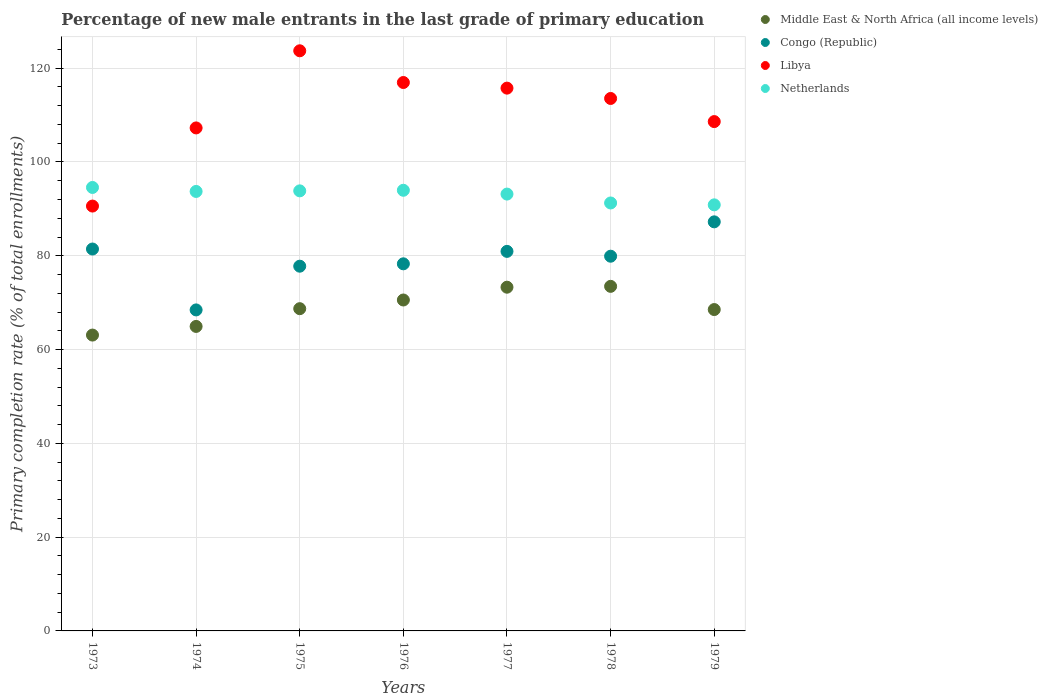How many different coloured dotlines are there?
Offer a very short reply. 4. What is the percentage of new male entrants in Middle East & North Africa (all income levels) in 1979?
Keep it short and to the point. 68.53. Across all years, what is the maximum percentage of new male entrants in Congo (Republic)?
Your answer should be very brief. 87.23. Across all years, what is the minimum percentage of new male entrants in Netherlands?
Offer a very short reply. 90.86. In which year was the percentage of new male entrants in Congo (Republic) maximum?
Give a very brief answer. 1979. In which year was the percentage of new male entrants in Netherlands minimum?
Offer a terse response. 1979. What is the total percentage of new male entrants in Libya in the graph?
Provide a short and direct response. 776.43. What is the difference between the percentage of new male entrants in Congo (Republic) in 1975 and that in 1976?
Provide a succinct answer. -0.51. What is the difference between the percentage of new male entrants in Netherlands in 1979 and the percentage of new male entrants in Middle East & North Africa (all income levels) in 1977?
Provide a succinct answer. 17.56. What is the average percentage of new male entrants in Congo (Republic) per year?
Offer a very short reply. 79.15. In the year 1976, what is the difference between the percentage of new male entrants in Libya and percentage of new male entrants in Middle East & North Africa (all income levels)?
Ensure brevity in your answer.  46.38. What is the ratio of the percentage of new male entrants in Congo (Republic) in 1975 to that in 1978?
Keep it short and to the point. 0.97. Is the percentage of new male entrants in Libya in 1975 less than that in 1979?
Your answer should be very brief. No. What is the difference between the highest and the second highest percentage of new male entrants in Congo (Republic)?
Your response must be concise. 5.8. What is the difference between the highest and the lowest percentage of new male entrants in Netherlands?
Your answer should be compact. 3.71. Is the sum of the percentage of new male entrants in Netherlands in 1973 and 1975 greater than the maximum percentage of new male entrants in Congo (Republic) across all years?
Your response must be concise. Yes. Is the percentage of new male entrants in Netherlands strictly less than the percentage of new male entrants in Libya over the years?
Make the answer very short. No. What is the difference between two consecutive major ticks on the Y-axis?
Offer a terse response. 20. Where does the legend appear in the graph?
Make the answer very short. Top right. How many legend labels are there?
Offer a terse response. 4. What is the title of the graph?
Provide a succinct answer. Percentage of new male entrants in the last grade of primary education. Does "Belgium" appear as one of the legend labels in the graph?
Give a very brief answer. No. What is the label or title of the X-axis?
Provide a short and direct response. Years. What is the label or title of the Y-axis?
Provide a short and direct response. Primary completion rate (% of total enrollments). What is the Primary completion rate (% of total enrollments) of Middle East & North Africa (all income levels) in 1973?
Make the answer very short. 63.09. What is the Primary completion rate (% of total enrollments) in Congo (Republic) in 1973?
Your response must be concise. 81.44. What is the Primary completion rate (% of total enrollments) of Libya in 1973?
Your answer should be very brief. 90.6. What is the Primary completion rate (% of total enrollments) in Netherlands in 1973?
Your answer should be compact. 94.57. What is the Primary completion rate (% of total enrollments) in Middle East & North Africa (all income levels) in 1974?
Ensure brevity in your answer.  64.93. What is the Primary completion rate (% of total enrollments) in Congo (Republic) in 1974?
Make the answer very short. 68.45. What is the Primary completion rate (% of total enrollments) of Libya in 1974?
Make the answer very short. 107.26. What is the Primary completion rate (% of total enrollments) in Netherlands in 1974?
Offer a terse response. 93.72. What is the Primary completion rate (% of total enrollments) of Middle East & North Africa (all income levels) in 1975?
Give a very brief answer. 68.72. What is the Primary completion rate (% of total enrollments) of Congo (Republic) in 1975?
Your answer should be compact. 77.78. What is the Primary completion rate (% of total enrollments) in Libya in 1975?
Your answer should be compact. 123.71. What is the Primary completion rate (% of total enrollments) of Netherlands in 1975?
Ensure brevity in your answer.  93.84. What is the Primary completion rate (% of total enrollments) of Middle East & North Africa (all income levels) in 1976?
Ensure brevity in your answer.  70.57. What is the Primary completion rate (% of total enrollments) of Congo (Republic) in 1976?
Your answer should be very brief. 78.28. What is the Primary completion rate (% of total enrollments) in Libya in 1976?
Give a very brief answer. 116.95. What is the Primary completion rate (% of total enrollments) of Netherlands in 1976?
Offer a terse response. 93.97. What is the Primary completion rate (% of total enrollments) of Middle East & North Africa (all income levels) in 1977?
Your answer should be compact. 73.3. What is the Primary completion rate (% of total enrollments) in Congo (Republic) in 1977?
Your answer should be very brief. 80.94. What is the Primary completion rate (% of total enrollments) of Libya in 1977?
Your answer should be very brief. 115.75. What is the Primary completion rate (% of total enrollments) in Netherlands in 1977?
Offer a terse response. 93.16. What is the Primary completion rate (% of total enrollments) in Middle East & North Africa (all income levels) in 1978?
Your answer should be compact. 73.48. What is the Primary completion rate (% of total enrollments) of Congo (Republic) in 1978?
Your response must be concise. 79.91. What is the Primary completion rate (% of total enrollments) of Libya in 1978?
Ensure brevity in your answer.  113.54. What is the Primary completion rate (% of total enrollments) of Netherlands in 1978?
Keep it short and to the point. 91.26. What is the Primary completion rate (% of total enrollments) in Middle East & North Africa (all income levels) in 1979?
Offer a terse response. 68.53. What is the Primary completion rate (% of total enrollments) in Congo (Republic) in 1979?
Ensure brevity in your answer.  87.23. What is the Primary completion rate (% of total enrollments) in Libya in 1979?
Keep it short and to the point. 108.61. What is the Primary completion rate (% of total enrollments) of Netherlands in 1979?
Keep it short and to the point. 90.86. Across all years, what is the maximum Primary completion rate (% of total enrollments) in Middle East & North Africa (all income levels)?
Make the answer very short. 73.48. Across all years, what is the maximum Primary completion rate (% of total enrollments) in Congo (Republic)?
Your answer should be compact. 87.23. Across all years, what is the maximum Primary completion rate (% of total enrollments) in Libya?
Your response must be concise. 123.71. Across all years, what is the maximum Primary completion rate (% of total enrollments) of Netherlands?
Make the answer very short. 94.57. Across all years, what is the minimum Primary completion rate (% of total enrollments) in Middle East & North Africa (all income levels)?
Provide a short and direct response. 63.09. Across all years, what is the minimum Primary completion rate (% of total enrollments) of Congo (Republic)?
Your response must be concise. 68.45. Across all years, what is the minimum Primary completion rate (% of total enrollments) in Libya?
Keep it short and to the point. 90.6. Across all years, what is the minimum Primary completion rate (% of total enrollments) in Netherlands?
Make the answer very short. 90.86. What is the total Primary completion rate (% of total enrollments) in Middle East & North Africa (all income levels) in the graph?
Your answer should be compact. 482.62. What is the total Primary completion rate (% of total enrollments) of Congo (Republic) in the graph?
Provide a succinct answer. 554.03. What is the total Primary completion rate (% of total enrollments) of Libya in the graph?
Make the answer very short. 776.43. What is the total Primary completion rate (% of total enrollments) of Netherlands in the graph?
Your answer should be compact. 651.37. What is the difference between the Primary completion rate (% of total enrollments) of Middle East & North Africa (all income levels) in 1973 and that in 1974?
Keep it short and to the point. -1.84. What is the difference between the Primary completion rate (% of total enrollments) in Congo (Republic) in 1973 and that in 1974?
Offer a terse response. 12.99. What is the difference between the Primary completion rate (% of total enrollments) in Libya in 1973 and that in 1974?
Ensure brevity in your answer.  -16.66. What is the difference between the Primary completion rate (% of total enrollments) of Netherlands in 1973 and that in 1974?
Keep it short and to the point. 0.85. What is the difference between the Primary completion rate (% of total enrollments) of Middle East & North Africa (all income levels) in 1973 and that in 1975?
Offer a terse response. -5.63. What is the difference between the Primary completion rate (% of total enrollments) in Congo (Republic) in 1973 and that in 1975?
Keep it short and to the point. 3.66. What is the difference between the Primary completion rate (% of total enrollments) of Libya in 1973 and that in 1975?
Provide a short and direct response. -33.11. What is the difference between the Primary completion rate (% of total enrollments) in Netherlands in 1973 and that in 1975?
Provide a short and direct response. 0.73. What is the difference between the Primary completion rate (% of total enrollments) in Middle East & North Africa (all income levels) in 1973 and that in 1976?
Give a very brief answer. -7.48. What is the difference between the Primary completion rate (% of total enrollments) in Congo (Republic) in 1973 and that in 1976?
Your answer should be very brief. 3.16. What is the difference between the Primary completion rate (% of total enrollments) of Libya in 1973 and that in 1976?
Keep it short and to the point. -26.35. What is the difference between the Primary completion rate (% of total enrollments) in Netherlands in 1973 and that in 1976?
Your answer should be compact. 0.6. What is the difference between the Primary completion rate (% of total enrollments) in Middle East & North Africa (all income levels) in 1973 and that in 1977?
Your answer should be compact. -10.21. What is the difference between the Primary completion rate (% of total enrollments) in Congo (Republic) in 1973 and that in 1977?
Offer a terse response. 0.5. What is the difference between the Primary completion rate (% of total enrollments) of Libya in 1973 and that in 1977?
Give a very brief answer. -25.15. What is the difference between the Primary completion rate (% of total enrollments) of Netherlands in 1973 and that in 1977?
Offer a very short reply. 1.41. What is the difference between the Primary completion rate (% of total enrollments) in Middle East & North Africa (all income levels) in 1973 and that in 1978?
Offer a terse response. -10.39. What is the difference between the Primary completion rate (% of total enrollments) in Congo (Republic) in 1973 and that in 1978?
Your answer should be very brief. 1.53. What is the difference between the Primary completion rate (% of total enrollments) of Libya in 1973 and that in 1978?
Offer a very short reply. -22.95. What is the difference between the Primary completion rate (% of total enrollments) of Netherlands in 1973 and that in 1978?
Ensure brevity in your answer.  3.31. What is the difference between the Primary completion rate (% of total enrollments) in Middle East & North Africa (all income levels) in 1973 and that in 1979?
Keep it short and to the point. -5.44. What is the difference between the Primary completion rate (% of total enrollments) in Congo (Republic) in 1973 and that in 1979?
Offer a terse response. -5.8. What is the difference between the Primary completion rate (% of total enrollments) of Libya in 1973 and that in 1979?
Your answer should be very brief. -18.01. What is the difference between the Primary completion rate (% of total enrollments) in Netherlands in 1973 and that in 1979?
Your response must be concise. 3.71. What is the difference between the Primary completion rate (% of total enrollments) in Middle East & North Africa (all income levels) in 1974 and that in 1975?
Ensure brevity in your answer.  -3.78. What is the difference between the Primary completion rate (% of total enrollments) in Congo (Republic) in 1974 and that in 1975?
Give a very brief answer. -9.32. What is the difference between the Primary completion rate (% of total enrollments) in Libya in 1974 and that in 1975?
Keep it short and to the point. -16.45. What is the difference between the Primary completion rate (% of total enrollments) of Netherlands in 1974 and that in 1975?
Your answer should be compact. -0.12. What is the difference between the Primary completion rate (% of total enrollments) in Middle East & North Africa (all income levels) in 1974 and that in 1976?
Keep it short and to the point. -5.63. What is the difference between the Primary completion rate (% of total enrollments) of Congo (Republic) in 1974 and that in 1976?
Give a very brief answer. -9.83. What is the difference between the Primary completion rate (% of total enrollments) of Libya in 1974 and that in 1976?
Give a very brief answer. -9.69. What is the difference between the Primary completion rate (% of total enrollments) in Netherlands in 1974 and that in 1976?
Offer a very short reply. -0.25. What is the difference between the Primary completion rate (% of total enrollments) in Middle East & North Africa (all income levels) in 1974 and that in 1977?
Keep it short and to the point. -8.37. What is the difference between the Primary completion rate (% of total enrollments) of Congo (Republic) in 1974 and that in 1977?
Your answer should be very brief. -12.48. What is the difference between the Primary completion rate (% of total enrollments) in Libya in 1974 and that in 1977?
Your answer should be very brief. -8.49. What is the difference between the Primary completion rate (% of total enrollments) of Netherlands in 1974 and that in 1977?
Keep it short and to the point. 0.56. What is the difference between the Primary completion rate (% of total enrollments) in Middle East & North Africa (all income levels) in 1974 and that in 1978?
Provide a short and direct response. -8.55. What is the difference between the Primary completion rate (% of total enrollments) of Congo (Republic) in 1974 and that in 1978?
Offer a very short reply. -11.45. What is the difference between the Primary completion rate (% of total enrollments) of Libya in 1974 and that in 1978?
Provide a succinct answer. -6.28. What is the difference between the Primary completion rate (% of total enrollments) in Netherlands in 1974 and that in 1978?
Your answer should be very brief. 2.46. What is the difference between the Primary completion rate (% of total enrollments) in Middle East & North Africa (all income levels) in 1974 and that in 1979?
Your answer should be compact. -3.6. What is the difference between the Primary completion rate (% of total enrollments) in Congo (Republic) in 1974 and that in 1979?
Keep it short and to the point. -18.78. What is the difference between the Primary completion rate (% of total enrollments) of Libya in 1974 and that in 1979?
Make the answer very short. -1.35. What is the difference between the Primary completion rate (% of total enrollments) of Netherlands in 1974 and that in 1979?
Give a very brief answer. 2.86. What is the difference between the Primary completion rate (% of total enrollments) of Middle East & North Africa (all income levels) in 1975 and that in 1976?
Your response must be concise. -1.85. What is the difference between the Primary completion rate (% of total enrollments) of Congo (Republic) in 1975 and that in 1976?
Keep it short and to the point. -0.51. What is the difference between the Primary completion rate (% of total enrollments) in Libya in 1975 and that in 1976?
Your response must be concise. 6.76. What is the difference between the Primary completion rate (% of total enrollments) in Netherlands in 1975 and that in 1976?
Your response must be concise. -0.12. What is the difference between the Primary completion rate (% of total enrollments) in Middle East & North Africa (all income levels) in 1975 and that in 1977?
Your response must be concise. -4.58. What is the difference between the Primary completion rate (% of total enrollments) of Congo (Republic) in 1975 and that in 1977?
Ensure brevity in your answer.  -3.16. What is the difference between the Primary completion rate (% of total enrollments) of Libya in 1975 and that in 1977?
Offer a terse response. 7.96. What is the difference between the Primary completion rate (% of total enrollments) in Netherlands in 1975 and that in 1977?
Provide a short and direct response. 0.69. What is the difference between the Primary completion rate (% of total enrollments) of Middle East & North Africa (all income levels) in 1975 and that in 1978?
Give a very brief answer. -4.76. What is the difference between the Primary completion rate (% of total enrollments) of Congo (Republic) in 1975 and that in 1978?
Ensure brevity in your answer.  -2.13. What is the difference between the Primary completion rate (% of total enrollments) in Libya in 1975 and that in 1978?
Your answer should be compact. 10.17. What is the difference between the Primary completion rate (% of total enrollments) of Netherlands in 1975 and that in 1978?
Make the answer very short. 2.58. What is the difference between the Primary completion rate (% of total enrollments) in Middle East & North Africa (all income levels) in 1975 and that in 1979?
Make the answer very short. 0.19. What is the difference between the Primary completion rate (% of total enrollments) of Congo (Republic) in 1975 and that in 1979?
Keep it short and to the point. -9.46. What is the difference between the Primary completion rate (% of total enrollments) in Libya in 1975 and that in 1979?
Provide a succinct answer. 15.1. What is the difference between the Primary completion rate (% of total enrollments) of Netherlands in 1975 and that in 1979?
Your answer should be compact. 2.98. What is the difference between the Primary completion rate (% of total enrollments) in Middle East & North Africa (all income levels) in 1976 and that in 1977?
Offer a terse response. -2.73. What is the difference between the Primary completion rate (% of total enrollments) of Congo (Republic) in 1976 and that in 1977?
Offer a terse response. -2.65. What is the difference between the Primary completion rate (% of total enrollments) of Libya in 1976 and that in 1977?
Your answer should be compact. 1.2. What is the difference between the Primary completion rate (% of total enrollments) of Netherlands in 1976 and that in 1977?
Keep it short and to the point. 0.81. What is the difference between the Primary completion rate (% of total enrollments) of Middle East & North Africa (all income levels) in 1976 and that in 1978?
Provide a succinct answer. -2.91. What is the difference between the Primary completion rate (% of total enrollments) of Congo (Republic) in 1976 and that in 1978?
Provide a short and direct response. -1.62. What is the difference between the Primary completion rate (% of total enrollments) of Libya in 1976 and that in 1978?
Provide a short and direct response. 3.4. What is the difference between the Primary completion rate (% of total enrollments) in Netherlands in 1976 and that in 1978?
Your answer should be very brief. 2.71. What is the difference between the Primary completion rate (% of total enrollments) of Middle East & North Africa (all income levels) in 1976 and that in 1979?
Give a very brief answer. 2.04. What is the difference between the Primary completion rate (% of total enrollments) of Congo (Republic) in 1976 and that in 1979?
Make the answer very short. -8.95. What is the difference between the Primary completion rate (% of total enrollments) of Libya in 1976 and that in 1979?
Make the answer very short. 8.33. What is the difference between the Primary completion rate (% of total enrollments) of Netherlands in 1976 and that in 1979?
Offer a terse response. 3.11. What is the difference between the Primary completion rate (% of total enrollments) of Middle East & North Africa (all income levels) in 1977 and that in 1978?
Provide a succinct answer. -0.18. What is the difference between the Primary completion rate (% of total enrollments) in Congo (Republic) in 1977 and that in 1978?
Make the answer very short. 1.03. What is the difference between the Primary completion rate (% of total enrollments) of Libya in 1977 and that in 1978?
Provide a succinct answer. 2.2. What is the difference between the Primary completion rate (% of total enrollments) in Netherlands in 1977 and that in 1978?
Give a very brief answer. 1.9. What is the difference between the Primary completion rate (% of total enrollments) of Middle East & North Africa (all income levels) in 1977 and that in 1979?
Give a very brief answer. 4.77. What is the difference between the Primary completion rate (% of total enrollments) of Congo (Republic) in 1977 and that in 1979?
Provide a succinct answer. -6.3. What is the difference between the Primary completion rate (% of total enrollments) of Libya in 1977 and that in 1979?
Your response must be concise. 7.13. What is the difference between the Primary completion rate (% of total enrollments) of Netherlands in 1977 and that in 1979?
Provide a succinct answer. 2.3. What is the difference between the Primary completion rate (% of total enrollments) of Middle East & North Africa (all income levels) in 1978 and that in 1979?
Offer a very short reply. 4.95. What is the difference between the Primary completion rate (% of total enrollments) of Congo (Republic) in 1978 and that in 1979?
Provide a short and direct response. -7.33. What is the difference between the Primary completion rate (% of total enrollments) in Libya in 1978 and that in 1979?
Your response must be concise. 4.93. What is the difference between the Primary completion rate (% of total enrollments) of Netherlands in 1978 and that in 1979?
Provide a succinct answer. 0.4. What is the difference between the Primary completion rate (% of total enrollments) in Middle East & North Africa (all income levels) in 1973 and the Primary completion rate (% of total enrollments) in Congo (Republic) in 1974?
Make the answer very short. -5.36. What is the difference between the Primary completion rate (% of total enrollments) of Middle East & North Africa (all income levels) in 1973 and the Primary completion rate (% of total enrollments) of Libya in 1974?
Offer a very short reply. -44.17. What is the difference between the Primary completion rate (% of total enrollments) of Middle East & North Africa (all income levels) in 1973 and the Primary completion rate (% of total enrollments) of Netherlands in 1974?
Give a very brief answer. -30.63. What is the difference between the Primary completion rate (% of total enrollments) of Congo (Republic) in 1973 and the Primary completion rate (% of total enrollments) of Libya in 1974?
Make the answer very short. -25.82. What is the difference between the Primary completion rate (% of total enrollments) of Congo (Republic) in 1973 and the Primary completion rate (% of total enrollments) of Netherlands in 1974?
Keep it short and to the point. -12.28. What is the difference between the Primary completion rate (% of total enrollments) in Libya in 1973 and the Primary completion rate (% of total enrollments) in Netherlands in 1974?
Your answer should be compact. -3.12. What is the difference between the Primary completion rate (% of total enrollments) in Middle East & North Africa (all income levels) in 1973 and the Primary completion rate (% of total enrollments) in Congo (Republic) in 1975?
Provide a succinct answer. -14.69. What is the difference between the Primary completion rate (% of total enrollments) of Middle East & North Africa (all income levels) in 1973 and the Primary completion rate (% of total enrollments) of Libya in 1975?
Your answer should be compact. -60.62. What is the difference between the Primary completion rate (% of total enrollments) in Middle East & North Africa (all income levels) in 1973 and the Primary completion rate (% of total enrollments) in Netherlands in 1975?
Your answer should be compact. -30.75. What is the difference between the Primary completion rate (% of total enrollments) in Congo (Republic) in 1973 and the Primary completion rate (% of total enrollments) in Libya in 1975?
Your answer should be compact. -42.27. What is the difference between the Primary completion rate (% of total enrollments) of Congo (Republic) in 1973 and the Primary completion rate (% of total enrollments) of Netherlands in 1975?
Your answer should be very brief. -12.4. What is the difference between the Primary completion rate (% of total enrollments) of Libya in 1973 and the Primary completion rate (% of total enrollments) of Netherlands in 1975?
Provide a succinct answer. -3.24. What is the difference between the Primary completion rate (% of total enrollments) in Middle East & North Africa (all income levels) in 1973 and the Primary completion rate (% of total enrollments) in Congo (Republic) in 1976?
Offer a very short reply. -15.19. What is the difference between the Primary completion rate (% of total enrollments) in Middle East & North Africa (all income levels) in 1973 and the Primary completion rate (% of total enrollments) in Libya in 1976?
Keep it short and to the point. -53.86. What is the difference between the Primary completion rate (% of total enrollments) of Middle East & North Africa (all income levels) in 1973 and the Primary completion rate (% of total enrollments) of Netherlands in 1976?
Give a very brief answer. -30.88. What is the difference between the Primary completion rate (% of total enrollments) of Congo (Republic) in 1973 and the Primary completion rate (% of total enrollments) of Libya in 1976?
Offer a terse response. -35.51. What is the difference between the Primary completion rate (% of total enrollments) in Congo (Republic) in 1973 and the Primary completion rate (% of total enrollments) in Netherlands in 1976?
Make the answer very short. -12.53. What is the difference between the Primary completion rate (% of total enrollments) in Libya in 1973 and the Primary completion rate (% of total enrollments) in Netherlands in 1976?
Offer a terse response. -3.37. What is the difference between the Primary completion rate (% of total enrollments) in Middle East & North Africa (all income levels) in 1973 and the Primary completion rate (% of total enrollments) in Congo (Republic) in 1977?
Your answer should be very brief. -17.85. What is the difference between the Primary completion rate (% of total enrollments) of Middle East & North Africa (all income levels) in 1973 and the Primary completion rate (% of total enrollments) of Libya in 1977?
Provide a short and direct response. -52.66. What is the difference between the Primary completion rate (% of total enrollments) in Middle East & North Africa (all income levels) in 1973 and the Primary completion rate (% of total enrollments) in Netherlands in 1977?
Your answer should be compact. -30.07. What is the difference between the Primary completion rate (% of total enrollments) in Congo (Republic) in 1973 and the Primary completion rate (% of total enrollments) in Libya in 1977?
Make the answer very short. -34.31. What is the difference between the Primary completion rate (% of total enrollments) in Congo (Republic) in 1973 and the Primary completion rate (% of total enrollments) in Netherlands in 1977?
Offer a terse response. -11.72. What is the difference between the Primary completion rate (% of total enrollments) of Libya in 1973 and the Primary completion rate (% of total enrollments) of Netherlands in 1977?
Offer a very short reply. -2.56. What is the difference between the Primary completion rate (% of total enrollments) of Middle East & North Africa (all income levels) in 1973 and the Primary completion rate (% of total enrollments) of Congo (Republic) in 1978?
Your answer should be compact. -16.82. What is the difference between the Primary completion rate (% of total enrollments) in Middle East & North Africa (all income levels) in 1973 and the Primary completion rate (% of total enrollments) in Libya in 1978?
Offer a very short reply. -50.45. What is the difference between the Primary completion rate (% of total enrollments) of Middle East & North Africa (all income levels) in 1973 and the Primary completion rate (% of total enrollments) of Netherlands in 1978?
Provide a short and direct response. -28.17. What is the difference between the Primary completion rate (% of total enrollments) of Congo (Republic) in 1973 and the Primary completion rate (% of total enrollments) of Libya in 1978?
Make the answer very short. -32.11. What is the difference between the Primary completion rate (% of total enrollments) in Congo (Republic) in 1973 and the Primary completion rate (% of total enrollments) in Netherlands in 1978?
Give a very brief answer. -9.82. What is the difference between the Primary completion rate (% of total enrollments) in Libya in 1973 and the Primary completion rate (% of total enrollments) in Netherlands in 1978?
Provide a short and direct response. -0.66. What is the difference between the Primary completion rate (% of total enrollments) of Middle East & North Africa (all income levels) in 1973 and the Primary completion rate (% of total enrollments) of Congo (Republic) in 1979?
Your answer should be compact. -24.14. What is the difference between the Primary completion rate (% of total enrollments) in Middle East & North Africa (all income levels) in 1973 and the Primary completion rate (% of total enrollments) in Libya in 1979?
Offer a very short reply. -45.52. What is the difference between the Primary completion rate (% of total enrollments) of Middle East & North Africa (all income levels) in 1973 and the Primary completion rate (% of total enrollments) of Netherlands in 1979?
Provide a short and direct response. -27.77. What is the difference between the Primary completion rate (% of total enrollments) in Congo (Republic) in 1973 and the Primary completion rate (% of total enrollments) in Libya in 1979?
Ensure brevity in your answer.  -27.18. What is the difference between the Primary completion rate (% of total enrollments) in Congo (Republic) in 1973 and the Primary completion rate (% of total enrollments) in Netherlands in 1979?
Offer a very short reply. -9.42. What is the difference between the Primary completion rate (% of total enrollments) in Libya in 1973 and the Primary completion rate (% of total enrollments) in Netherlands in 1979?
Give a very brief answer. -0.26. What is the difference between the Primary completion rate (% of total enrollments) of Middle East & North Africa (all income levels) in 1974 and the Primary completion rate (% of total enrollments) of Congo (Republic) in 1975?
Keep it short and to the point. -12.84. What is the difference between the Primary completion rate (% of total enrollments) of Middle East & North Africa (all income levels) in 1974 and the Primary completion rate (% of total enrollments) of Libya in 1975?
Keep it short and to the point. -58.78. What is the difference between the Primary completion rate (% of total enrollments) in Middle East & North Africa (all income levels) in 1974 and the Primary completion rate (% of total enrollments) in Netherlands in 1975?
Offer a very short reply. -28.91. What is the difference between the Primary completion rate (% of total enrollments) of Congo (Republic) in 1974 and the Primary completion rate (% of total enrollments) of Libya in 1975?
Your answer should be compact. -55.26. What is the difference between the Primary completion rate (% of total enrollments) in Congo (Republic) in 1974 and the Primary completion rate (% of total enrollments) in Netherlands in 1975?
Make the answer very short. -25.39. What is the difference between the Primary completion rate (% of total enrollments) of Libya in 1974 and the Primary completion rate (% of total enrollments) of Netherlands in 1975?
Give a very brief answer. 13.42. What is the difference between the Primary completion rate (% of total enrollments) in Middle East & North Africa (all income levels) in 1974 and the Primary completion rate (% of total enrollments) in Congo (Republic) in 1976?
Provide a short and direct response. -13.35. What is the difference between the Primary completion rate (% of total enrollments) of Middle East & North Africa (all income levels) in 1974 and the Primary completion rate (% of total enrollments) of Libya in 1976?
Give a very brief answer. -52.01. What is the difference between the Primary completion rate (% of total enrollments) of Middle East & North Africa (all income levels) in 1974 and the Primary completion rate (% of total enrollments) of Netherlands in 1976?
Offer a very short reply. -29.03. What is the difference between the Primary completion rate (% of total enrollments) of Congo (Republic) in 1974 and the Primary completion rate (% of total enrollments) of Libya in 1976?
Make the answer very short. -48.5. What is the difference between the Primary completion rate (% of total enrollments) of Congo (Republic) in 1974 and the Primary completion rate (% of total enrollments) of Netherlands in 1976?
Your answer should be very brief. -25.51. What is the difference between the Primary completion rate (% of total enrollments) in Libya in 1974 and the Primary completion rate (% of total enrollments) in Netherlands in 1976?
Ensure brevity in your answer.  13.3. What is the difference between the Primary completion rate (% of total enrollments) in Middle East & North Africa (all income levels) in 1974 and the Primary completion rate (% of total enrollments) in Congo (Republic) in 1977?
Your response must be concise. -16. What is the difference between the Primary completion rate (% of total enrollments) of Middle East & North Africa (all income levels) in 1974 and the Primary completion rate (% of total enrollments) of Libya in 1977?
Provide a short and direct response. -50.82. What is the difference between the Primary completion rate (% of total enrollments) of Middle East & North Africa (all income levels) in 1974 and the Primary completion rate (% of total enrollments) of Netherlands in 1977?
Your answer should be very brief. -28.22. What is the difference between the Primary completion rate (% of total enrollments) in Congo (Republic) in 1974 and the Primary completion rate (% of total enrollments) in Libya in 1977?
Give a very brief answer. -47.3. What is the difference between the Primary completion rate (% of total enrollments) in Congo (Republic) in 1974 and the Primary completion rate (% of total enrollments) in Netherlands in 1977?
Offer a terse response. -24.7. What is the difference between the Primary completion rate (% of total enrollments) in Libya in 1974 and the Primary completion rate (% of total enrollments) in Netherlands in 1977?
Ensure brevity in your answer.  14.11. What is the difference between the Primary completion rate (% of total enrollments) in Middle East & North Africa (all income levels) in 1974 and the Primary completion rate (% of total enrollments) in Congo (Republic) in 1978?
Keep it short and to the point. -14.97. What is the difference between the Primary completion rate (% of total enrollments) of Middle East & North Africa (all income levels) in 1974 and the Primary completion rate (% of total enrollments) of Libya in 1978?
Offer a very short reply. -48.61. What is the difference between the Primary completion rate (% of total enrollments) of Middle East & North Africa (all income levels) in 1974 and the Primary completion rate (% of total enrollments) of Netherlands in 1978?
Provide a succinct answer. -26.33. What is the difference between the Primary completion rate (% of total enrollments) of Congo (Republic) in 1974 and the Primary completion rate (% of total enrollments) of Libya in 1978?
Make the answer very short. -45.09. What is the difference between the Primary completion rate (% of total enrollments) of Congo (Republic) in 1974 and the Primary completion rate (% of total enrollments) of Netherlands in 1978?
Provide a succinct answer. -22.81. What is the difference between the Primary completion rate (% of total enrollments) of Libya in 1974 and the Primary completion rate (% of total enrollments) of Netherlands in 1978?
Offer a very short reply. 16. What is the difference between the Primary completion rate (% of total enrollments) of Middle East & North Africa (all income levels) in 1974 and the Primary completion rate (% of total enrollments) of Congo (Republic) in 1979?
Your answer should be very brief. -22.3. What is the difference between the Primary completion rate (% of total enrollments) of Middle East & North Africa (all income levels) in 1974 and the Primary completion rate (% of total enrollments) of Libya in 1979?
Provide a succinct answer. -43.68. What is the difference between the Primary completion rate (% of total enrollments) in Middle East & North Africa (all income levels) in 1974 and the Primary completion rate (% of total enrollments) in Netherlands in 1979?
Ensure brevity in your answer.  -25.92. What is the difference between the Primary completion rate (% of total enrollments) of Congo (Republic) in 1974 and the Primary completion rate (% of total enrollments) of Libya in 1979?
Offer a very short reply. -40.16. What is the difference between the Primary completion rate (% of total enrollments) of Congo (Republic) in 1974 and the Primary completion rate (% of total enrollments) of Netherlands in 1979?
Your answer should be very brief. -22.41. What is the difference between the Primary completion rate (% of total enrollments) in Libya in 1974 and the Primary completion rate (% of total enrollments) in Netherlands in 1979?
Your answer should be compact. 16.4. What is the difference between the Primary completion rate (% of total enrollments) of Middle East & North Africa (all income levels) in 1975 and the Primary completion rate (% of total enrollments) of Congo (Republic) in 1976?
Offer a terse response. -9.57. What is the difference between the Primary completion rate (% of total enrollments) in Middle East & North Africa (all income levels) in 1975 and the Primary completion rate (% of total enrollments) in Libya in 1976?
Your response must be concise. -48.23. What is the difference between the Primary completion rate (% of total enrollments) in Middle East & North Africa (all income levels) in 1975 and the Primary completion rate (% of total enrollments) in Netherlands in 1976?
Your response must be concise. -25.25. What is the difference between the Primary completion rate (% of total enrollments) of Congo (Republic) in 1975 and the Primary completion rate (% of total enrollments) of Libya in 1976?
Offer a very short reply. -39.17. What is the difference between the Primary completion rate (% of total enrollments) in Congo (Republic) in 1975 and the Primary completion rate (% of total enrollments) in Netherlands in 1976?
Your response must be concise. -16.19. What is the difference between the Primary completion rate (% of total enrollments) of Libya in 1975 and the Primary completion rate (% of total enrollments) of Netherlands in 1976?
Offer a very short reply. 29.75. What is the difference between the Primary completion rate (% of total enrollments) in Middle East & North Africa (all income levels) in 1975 and the Primary completion rate (% of total enrollments) in Congo (Republic) in 1977?
Keep it short and to the point. -12.22. What is the difference between the Primary completion rate (% of total enrollments) in Middle East & North Africa (all income levels) in 1975 and the Primary completion rate (% of total enrollments) in Libya in 1977?
Provide a short and direct response. -47.03. What is the difference between the Primary completion rate (% of total enrollments) of Middle East & North Africa (all income levels) in 1975 and the Primary completion rate (% of total enrollments) of Netherlands in 1977?
Provide a succinct answer. -24.44. What is the difference between the Primary completion rate (% of total enrollments) of Congo (Republic) in 1975 and the Primary completion rate (% of total enrollments) of Libya in 1977?
Your answer should be compact. -37.97. What is the difference between the Primary completion rate (% of total enrollments) in Congo (Republic) in 1975 and the Primary completion rate (% of total enrollments) in Netherlands in 1977?
Provide a succinct answer. -15.38. What is the difference between the Primary completion rate (% of total enrollments) of Libya in 1975 and the Primary completion rate (% of total enrollments) of Netherlands in 1977?
Your response must be concise. 30.56. What is the difference between the Primary completion rate (% of total enrollments) of Middle East & North Africa (all income levels) in 1975 and the Primary completion rate (% of total enrollments) of Congo (Republic) in 1978?
Provide a short and direct response. -11.19. What is the difference between the Primary completion rate (% of total enrollments) in Middle East & North Africa (all income levels) in 1975 and the Primary completion rate (% of total enrollments) in Libya in 1978?
Ensure brevity in your answer.  -44.83. What is the difference between the Primary completion rate (% of total enrollments) in Middle East & North Africa (all income levels) in 1975 and the Primary completion rate (% of total enrollments) in Netherlands in 1978?
Your answer should be compact. -22.54. What is the difference between the Primary completion rate (% of total enrollments) of Congo (Republic) in 1975 and the Primary completion rate (% of total enrollments) of Libya in 1978?
Make the answer very short. -35.77. What is the difference between the Primary completion rate (% of total enrollments) of Congo (Republic) in 1975 and the Primary completion rate (% of total enrollments) of Netherlands in 1978?
Your response must be concise. -13.48. What is the difference between the Primary completion rate (% of total enrollments) in Libya in 1975 and the Primary completion rate (% of total enrollments) in Netherlands in 1978?
Provide a short and direct response. 32.45. What is the difference between the Primary completion rate (% of total enrollments) in Middle East & North Africa (all income levels) in 1975 and the Primary completion rate (% of total enrollments) in Congo (Republic) in 1979?
Make the answer very short. -18.52. What is the difference between the Primary completion rate (% of total enrollments) in Middle East & North Africa (all income levels) in 1975 and the Primary completion rate (% of total enrollments) in Libya in 1979?
Keep it short and to the point. -39.9. What is the difference between the Primary completion rate (% of total enrollments) in Middle East & North Africa (all income levels) in 1975 and the Primary completion rate (% of total enrollments) in Netherlands in 1979?
Give a very brief answer. -22.14. What is the difference between the Primary completion rate (% of total enrollments) of Congo (Republic) in 1975 and the Primary completion rate (% of total enrollments) of Libya in 1979?
Provide a succinct answer. -30.84. What is the difference between the Primary completion rate (% of total enrollments) of Congo (Republic) in 1975 and the Primary completion rate (% of total enrollments) of Netherlands in 1979?
Provide a succinct answer. -13.08. What is the difference between the Primary completion rate (% of total enrollments) in Libya in 1975 and the Primary completion rate (% of total enrollments) in Netherlands in 1979?
Keep it short and to the point. 32.85. What is the difference between the Primary completion rate (% of total enrollments) in Middle East & North Africa (all income levels) in 1976 and the Primary completion rate (% of total enrollments) in Congo (Republic) in 1977?
Your answer should be very brief. -10.37. What is the difference between the Primary completion rate (% of total enrollments) in Middle East & North Africa (all income levels) in 1976 and the Primary completion rate (% of total enrollments) in Libya in 1977?
Provide a short and direct response. -45.18. What is the difference between the Primary completion rate (% of total enrollments) in Middle East & North Africa (all income levels) in 1976 and the Primary completion rate (% of total enrollments) in Netherlands in 1977?
Your response must be concise. -22.59. What is the difference between the Primary completion rate (% of total enrollments) in Congo (Republic) in 1976 and the Primary completion rate (% of total enrollments) in Libya in 1977?
Your answer should be compact. -37.47. What is the difference between the Primary completion rate (% of total enrollments) of Congo (Republic) in 1976 and the Primary completion rate (% of total enrollments) of Netherlands in 1977?
Offer a very short reply. -14.87. What is the difference between the Primary completion rate (% of total enrollments) of Libya in 1976 and the Primary completion rate (% of total enrollments) of Netherlands in 1977?
Offer a very short reply. 23.79. What is the difference between the Primary completion rate (% of total enrollments) of Middle East & North Africa (all income levels) in 1976 and the Primary completion rate (% of total enrollments) of Congo (Republic) in 1978?
Make the answer very short. -9.34. What is the difference between the Primary completion rate (% of total enrollments) in Middle East & North Africa (all income levels) in 1976 and the Primary completion rate (% of total enrollments) in Libya in 1978?
Provide a short and direct response. -42.98. What is the difference between the Primary completion rate (% of total enrollments) of Middle East & North Africa (all income levels) in 1976 and the Primary completion rate (% of total enrollments) of Netherlands in 1978?
Your response must be concise. -20.69. What is the difference between the Primary completion rate (% of total enrollments) in Congo (Republic) in 1976 and the Primary completion rate (% of total enrollments) in Libya in 1978?
Keep it short and to the point. -35.26. What is the difference between the Primary completion rate (% of total enrollments) of Congo (Republic) in 1976 and the Primary completion rate (% of total enrollments) of Netherlands in 1978?
Your answer should be compact. -12.98. What is the difference between the Primary completion rate (% of total enrollments) in Libya in 1976 and the Primary completion rate (% of total enrollments) in Netherlands in 1978?
Your answer should be compact. 25.69. What is the difference between the Primary completion rate (% of total enrollments) of Middle East & North Africa (all income levels) in 1976 and the Primary completion rate (% of total enrollments) of Congo (Republic) in 1979?
Ensure brevity in your answer.  -16.67. What is the difference between the Primary completion rate (% of total enrollments) in Middle East & North Africa (all income levels) in 1976 and the Primary completion rate (% of total enrollments) in Libya in 1979?
Offer a terse response. -38.05. What is the difference between the Primary completion rate (% of total enrollments) of Middle East & North Africa (all income levels) in 1976 and the Primary completion rate (% of total enrollments) of Netherlands in 1979?
Ensure brevity in your answer.  -20.29. What is the difference between the Primary completion rate (% of total enrollments) in Congo (Republic) in 1976 and the Primary completion rate (% of total enrollments) in Libya in 1979?
Make the answer very short. -30.33. What is the difference between the Primary completion rate (% of total enrollments) of Congo (Republic) in 1976 and the Primary completion rate (% of total enrollments) of Netherlands in 1979?
Offer a very short reply. -12.58. What is the difference between the Primary completion rate (% of total enrollments) in Libya in 1976 and the Primary completion rate (% of total enrollments) in Netherlands in 1979?
Provide a short and direct response. 26.09. What is the difference between the Primary completion rate (% of total enrollments) in Middle East & North Africa (all income levels) in 1977 and the Primary completion rate (% of total enrollments) in Congo (Republic) in 1978?
Offer a very short reply. -6.61. What is the difference between the Primary completion rate (% of total enrollments) of Middle East & North Africa (all income levels) in 1977 and the Primary completion rate (% of total enrollments) of Libya in 1978?
Keep it short and to the point. -40.25. What is the difference between the Primary completion rate (% of total enrollments) in Middle East & North Africa (all income levels) in 1977 and the Primary completion rate (% of total enrollments) in Netherlands in 1978?
Ensure brevity in your answer.  -17.96. What is the difference between the Primary completion rate (% of total enrollments) in Congo (Republic) in 1977 and the Primary completion rate (% of total enrollments) in Libya in 1978?
Your response must be concise. -32.61. What is the difference between the Primary completion rate (% of total enrollments) in Congo (Republic) in 1977 and the Primary completion rate (% of total enrollments) in Netherlands in 1978?
Your answer should be very brief. -10.32. What is the difference between the Primary completion rate (% of total enrollments) of Libya in 1977 and the Primary completion rate (% of total enrollments) of Netherlands in 1978?
Provide a short and direct response. 24.49. What is the difference between the Primary completion rate (% of total enrollments) of Middle East & North Africa (all income levels) in 1977 and the Primary completion rate (% of total enrollments) of Congo (Republic) in 1979?
Your answer should be very brief. -13.94. What is the difference between the Primary completion rate (% of total enrollments) of Middle East & North Africa (all income levels) in 1977 and the Primary completion rate (% of total enrollments) of Libya in 1979?
Offer a very short reply. -35.32. What is the difference between the Primary completion rate (% of total enrollments) in Middle East & North Africa (all income levels) in 1977 and the Primary completion rate (% of total enrollments) in Netherlands in 1979?
Provide a succinct answer. -17.56. What is the difference between the Primary completion rate (% of total enrollments) of Congo (Republic) in 1977 and the Primary completion rate (% of total enrollments) of Libya in 1979?
Your answer should be compact. -27.68. What is the difference between the Primary completion rate (% of total enrollments) in Congo (Republic) in 1977 and the Primary completion rate (% of total enrollments) in Netherlands in 1979?
Provide a succinct answer. -9.92. What is the difference between the Primary completion rate (% of total enrollments) in Libya in 1977 and the Primary completion rate (% of total enrollments) in Netherlands in 1979?
Your answer should be compact. 24.89. What is the difference between the Primary completion rate (% of total enrollments) of Middle East & North Africa (all income levels) in 1978 and the Primary completion rate (% of total enrollments) of Congo (Republic) in 1979?
Provide a succinct answer. -13.76. What is the difference between the Primary completion rate (% of total enrollments) in Middle East & North Africa (all income levels) in 1978 and the Primary completion rate (% of total enrollments) in Libya in 1979?
Provide a short and direct response. -35.13. What is the difference between the Primary completion rate (% of total enrollments) in Middle East & North Africa (all income levels) in 1978 and the Primary completion rate (% of total enrollments) in Netherlands in 1979?
Give a very brief answer. -17.38. What is the difference between the Primary completion rate (% of total enrollments) of Congo (Republic) in 1978 and the Primary completion rate (% of total enrollments) of Libya in 1979?
Your answer should be compact. -28.71. What is the difference between the Primary completion rate (% of total enrollments) in Congo (Republic) in 1978 and the Primary completion rate (% of total enrollments) in Netherlands in 1979?
Offer a very short reply. -10.95. What is the difference between the Primary completion rate (% of total enrollments) of Libya in 1978 and the Primary completion rate (% of total enrollments) of Netherlands in 1979?
Your response must be concise. 22.69. What is the average Primary completion rate (% of total enrollments) in Middle East & North Africa (all income levels) per year?
Keep it short and to the point. 68.95. What is the average Primary completion rate (% of total enrollments) in Congo (Republic) per year?
Offer a terse response. 79.15. What is the average Primary completion rate (% of total enrollments) in Libya per year?
Your response must be concise. 110.92. What is the average Primary completion rate (% of total enrollments) in Netherlands per year?
Provide a short and direct response. 93.05. In the year 1973, what is the difference between the Primary completion rate (% of total enrollments) of Middle East & North Africa (all income levels) and Primary completion rate (% of total enrollments) of Congo (Republic)?
Your answer should be very brief. -18.35. In the year 1973, what is the difference between the Primary completion rate (% of total enrollments) in Middle East & North Africa (all income levels) and Primary completion rate (% of total enrollments) in Libya?
Provide a succinct answer. -27.51. In the year 1973, what is the difference between the Primary completion rate (% of total enrollments) of Middle East & North Africa (all income levels) and Primary completion rate (% of total enrollments) of Netherlands?
Provide a short and direct response. -31.48. In the year 1973, what is the difference between the Primary completion rate (% of total enrollments) in Congo (Republic) and Primary completion rate (% of total enrollments) in Libya?
Your response must be concise. -9.16. In the year 1973, what is the difference between the Primary completion rate (% of total enrollments) of Congo (Republic) and Primary completion rate (% of total enrollments) of Netherlands?
Offer a terse response. -13.13. In the year 1973, what is the difference between the Primary completion rate (% of total enrollments) in Libya and Primary completion rate (% of total enrollments) in Netherlands?
Your response must be concise. -3.97. In the year 1974, what is the difference between the Primary completion rate (% of total enrollments) in Middle East & North Africa (all income levels) and Primary completion rate (% of total enrollments) in Congo (Republic)?
Your answer should be very brief. -3.52. In the year 1974, what is the difference between the Primary completion rate (% of total enrollments) of Middle East & North Africa (all income levels) and Primary completion rate (% of total enrollments) of Libya?
Your answer should be very brief. -42.33. In the year 1974, what is the difference between the Primary completion rate (% of total enrollments) in Middle East & North Africa (all income levels) and Primary completion rate (% of total enrollments) in Netherlands?
Ensure brevity in your answer.  -28.78. In the year 1974, what is the difference between the Primary completion rate (% of total enrollments) of Congo (Republic) and Primary completion rate (% of total enrollments) of Libya?
Make the answer very short. -38.81. In the year 1974, what is the difference between the Primary completion rate (% of total enrollments) of Congo (Republic) and Primary completion rate (% of total enrollments) of Netherlands?
Ensure brevity in your answer.  -25.26. In the year 1974, what is the difference between the Primary completion rate (% of total enrollments) in Libya and Primary completion rate (% of total enrollments) in Netherlands?
Provide a short and direct response. 13.55. In the year 1975, what is the difference between the Primary completion rate (% of total enrollments) in Middle East & North Africa (all income levels) and Primary completion rate (% of total enrollments) in Congo (Republic)?
Keep it short and to the point. -9.06. In the year 1975, what is the difference between the Primary completion rate (% of total enrollments) in Middle East & North Africa (all income levels) and Primary completion rate (% of total enrollments) in Libya?
Your response must be concise. -54.99. In the year 1975, what is the difference between the Primary completion rate (% of total enrollments) of Middle East & North Africa (all income levels) and Primary completion rate (% of total enrollments) of Netherlands?
Offer a very short reply. -25.12. In the year 1975, what is the difference between the Primary completion rate (% of total enrollments) in Congo (Republic) and Primary completion rate (% of total enrollments) in Libya?
Your answer should be very brief. -45.93. In the year 1975, what is the difference between the Primary completion rate (% of total enrollments) of Congo (Republic) and Primary completion rate (% of total enrollments) of Netherlands?
Give a very brief answer. -16.06. In the year 1975, what is the difference between the Primary completion rate (% of total enrollments) in Libya and Primary completion rate (% of total enrollments) in Netherlands?
Your answer should be very brief. 29.87. In the year 1976, what is the difference between the Primary completion rate (% of total enrollments) in Middle East & North Africa (all income levels) and Primary completion rate (% of total enrollments) in Congo (Republic)?
Keep it short and to the point. -7.71. In the year 1976, what is the difference between the Primary completion rate (% of total enrollments) in Middle East & North Africa (all income levels) and Primary completion rate (% of total enrollments) in Libya?
Give a very brief answer. -46.38. In the year 1976, what is the difference between the Primary completion rate (% of total enrollments) of Middle East & North Africa (all income levels) and Primary completion rate (% of total enrollments) of Netherlands?
Your answer should be compact. -23.4. In the year 1976, what is the difference between the Primary completion rate (% of total enrollments) of Congo (Republic) and Primary completion rate (% of total enrollments) of Libya?
Give a very brief answer. -38.67. In the year 1976, what is the difference between the Primary completion rate (% of total enrollments) of Congo (Republic) and Primary completion rate (% of total enrollments) of Netherlands?
Your answer should be very brief. -15.68. In the year 1976, what is the difference between the Primary completion rate (% of total enrollments) in Libya and Primary completion rate (% of total enrollments) in Netherlands?
Keep it short and to the point. 22.98. In the year 1977, what is the difference between the Primary completion rate (% of total enrollments) of Middle East & North Africa (all income levels) and Primary completion rate (% of total enrollments) of Congo (Republic)?
Make the answer very short. -7.64. In the year 1977, what is the difference between the Primary completion rate (% of total enrollments) in Middle East & North Africa (all income levels) and Primary completion rate (% of total enrollments) in Libya?
Your answer should be compact. -42.45. In the year 1977, what is the difference between the Primary completion rate (% of total enrollments) in Middle East & North Africa (all income levels) and Primary completion rate (% of total enrollments) in Netherlands?
Provide a short and direct response. -19.86. In the year 1977, what is the difference between the Primary completion rate (% of total enrollments) of Congo (Republic) and Primary completion rate (% of total enrollments) of Libya?
Your answer should be compact. -34.81. In the year 1977, what is the difference between the Primary completion rate (% of total enrollments) of Congo (Republic) and Primary completion rate (% of total enrollments) of Netherlands?
Ensure brevity in your answer.  -12.22. In the year 1977, what is the difference between the Primary completion rate (% of total enrollments) of Libya and Primary completion rate (% of total enrollments) of Netherlands?
Your answer should be very brief. 22.59. In the year 1978, what is the difference between the Primary completion rate (% of total enrollments) in Middle East & North Africa (all income levels) and Primary completion rate (% of total enrollments) in Congo (Republic)?
Ensure brevity in your answer.  -6.43. In the year 1978, what is the difference between the Primary completion rate (% of total enrollments) of Middle East & North Africa (all income levels) and Primary completion rate (% of total enrollments) of Libya?
Offer a very short reply. -40.07. In the year 1978, what is the difference between the Primary completion rate (% of total enrollments) in Middle East & North Africa (all income levels) and Primary completion rate (% of total enrollments) in Netherlands?
Make the answer very short. -17.78. In the year 1978, what is the difference between the Primary completion rate (% of total enrollments) in Congo (Republic) and Primary completion rate (% of total enrollments) in Libya?
Make the answer very short. -33.64. In the year 1978, what is the difference between the Primary completion rate (% of total enrollments) in Congo (Republic) and Primary completion rate (% of total enrollments) in Netherlands?
Ensure brevity in your answer.  -11.35. In the year 1978, what is the difference between the Primary completion rate (% of total enrollments) in Libya and Primary completion rate (% of total enrollments) in Netherlands?
Provide a short and direct response. 22.29. In the year 1979, what is the difference between the Primary completion rate (% of total enrollments) of Middle East & North Africa (all income levels) and Primary completion rate (% of total enrollments) of Congo (Republic)?
Provide a short and direct response. -18.7. In the year 1979, what is the difference between the Primary completion rate (% of total enrollments) in Middle East & North Africa (all income levels) and Primary completion rate (% of total enrollments) in Libya?
Give a very brief answer. -40.08. In the year 1979, what is the difference between the Primary completion rate (% of total enrollments) of Middle East & North Africa (all income levels) and Primary completion rate (% of total enrollments) of Netherlands?
Offer a very short reply. -22.33. In the year 1979, what is the difference between the Primary completion rate (% of total enrollments) in Congo (Republic) and Primary completion rate (% of total enrollments) in Libya?
Ensure brevity in your answer.  -21.38. In the year 1979, what is the difference between the Primary completion rate (% of total enrollments) of Congo (Republic) and Primary completion rate (% of total enrollments) of Netherlands?
Offer a very short reply. -3.62. In the year 1979, what is the difference between the Primary completion rate (% of total enrollments) in Libya and Primary completion rate (% of total enrollments) in Netherlands?
Your response must be concise. 17.76. What is the ratio of the Primary completion rate (% of total enrollments) of Middle East & North Africa (all income levels) in 1973 to that in 1974?
Offer a terse response. 0.97. What is the ratio of the Primary completion rate (% of total enrollments) in Congo (Republic) in 1973 to that in 1974?
Your answer should be very brief. 1.19. What is the ratio of the Primary completion rate (% of total enrollments) of Libya in 1973 to that in 1974?
Make the answer very short. 0.84. What is the ratio of the Primary completion rate (% of total enrollments) in Netherlands in 1973 to that in 1974?
Provide a succinct answer. 1.01. What is the ratio of the Primary completion rate (% of total enrollments) in Middle East & North Africa (all income levels) in 1973 to that in 1975?
Your response must be concise. 0.92. What is the ratio of the Primary completion rate (% of total enrollments) in Congo (Republic) in 1973 to that in 1975?
Offer a terse response. 1.05. What is the ratio of the Primary completion rate (% of total enrollments) of Libya in 1973 to that in 1975?
Your response must be concise. 0.73. What is the ratio of the Primary completion rate (% of total enrollments) of Netherlands in 1973 to that in 1975?
Your answer should be compact. 1.01. What is the ratio of the Primary completion rate (% of total enrollments) in Middle East & North Africa (all income levels) in 1973 to that in 1976?
Offer a terse response. 0.89. What is the ratio of the Primary completion rate (% of total enrollments) in Congo (Republic) in 1973 to that in 1976?
Provide a short and direct response. 1.04. What is the ratio of the Primary completion rate (% of total enrollments) in Libya in 1973 to that in 1976?
Keep it short and to the point. 0.77. What is the ratio of the Primary completion rate (% of total enrollments) in Netherlands in 1973 to that in 1976?
Offer a terse response. 1.01. What is the ratio of the Primary completion rate (% of total enrollments) in Middle East & North Africa (all income levels) in 1973 to that in 1977?
Your answer should be compact. 0.86. What is the ratio of the Primary completion rate (% of total enrollments) of Libya in 1973 to that in 1977?
Offer a very short reply. 0.78. What is the ratio of the Primary completion rate (% of total enrollments) of Netherlands in 1973 to that in 1977?
Provide a short and direct response. 1.02. What is the ratio of the Primary completion rate (% of total enrollments) in Middle East & North Africa (all income levels) in 1973 to that in 1978?
Your response must be concise. 0.86. What is the ratio of the Primary completion rate (% of total enrollments) in Congo (Republic) in 1973 to that in 1978?
Offer a terse response. 1.02. What is the ratio of the Primary completion rate (% of total enrollments) in Libya in 1973 to that in 1978?
Offer a terse response. 0.8. What is the ratio of the Primary completion rate (% of total enrollments) in Netherlands in 1973 to that in 1978?
Provide a succinct answer. 1.04. What is the ratio of the Primary completion rate (% of total enrollments) of Middle East & North Africa (all income levels) in 1973 to that in 1979?
Offer a very short reply. 0.92. What is the ratio of the Primary completion rate (% of total enrollments) of Congo (Republic) in 1973 to that in 1979?
Make the answer very short. 0.93. What is the ratio of the Primary completion rate (% of total enrollments) of Libya in 1973 to that in 1979?
Offer a very short reply. 0.83. What is the ratio of the Primary completion rate (% of total enrollments) of Netherlands in 1973 to that in 1979?
Your answer should be compact. 1.04. What is the ratio of the Primary completion rate (% of total enrollments) in Middle East & North Africa (all income levels) in 1974 to that in 1975?
Make the answer very short. 0.94. What is the ratio of the Primary completion rate (% of total enrollments) of Congo (Republic) in 1974 to that in 1975?
Make the answer very short. 0.88. What is the ratio of the Primary completion rate (% of total enrollments) in Libya in 1974 to that in 1975?
Ensure brevity in your answer.  0.87. What is the ratio of the Primary completion rate (% of total enrollments) of Netherlands in 1974 to that in 1975?
Your answer should be compact. 1. What is the ratio of the Primary completion rate (% of total enrollments) in Middle East & North Africa (all income levels) in 1974 to that in 1976?
Keep it short and to the point. 0.92. What is the ratio of the Primary completion rate (% of total enrollments) of Congo (Republic) in 1974 to that in 1976?
Keep it short and to the point. 0.87. What is the ratio of the Primary completion rate (% of total enrollments) in Libya in 1974 to that in 1976?
Provide a short and direct response. 0.92. What is the ratio of the Primary completion rate (% of total enrollments) of Netherlands in 1974 to that in 1976?
Provide a short and direct response. 1. What is the ratio of the Primary completion rate (% of total enrollments) of Middle East & North Africa (all income levels) in 1974 to that in 1977?
Give a very brief answer. 0.89. What is the ratio of the Primary completion rate (% of total enrollments) of Congo (Republic) in 1974 to that in 1977?
Provide a succinct answer. 0.85. What is the ratio of the Primary completion rate (% of total enrollments) in Libya in 1974 to that in 1977?
Your answer should be compact. 0.93. What is the ratio of the Primary completion rate (% of total enrollments) in Netherlands in 1974 to that in 1977?
Your response must be concise. 1.01. What is the ratio of the Primary completion rate (% of total enrollments) in Middle East & North Africa (all income levels) in 1974 to that in 1978?
Your response must be concise. 0.88. What is the ratio of the Primary completion rate (% of total enrollments) in Congo (Republic) in 1974 to that in 1978?
Your response must be concise. 0.86. What is the ratio of the Primary completion rate (% of total enrollments) of Libya in 1974 to that in 1978?
Your answer should be compact. 0.94. What is the ratio of the Primary completion rate (% of total enrollments) of Netherlands in 1974 to that in 1978?
Your response must be concise. 1.03. What is the ratio of the Primary completion rate (% of total enrollments) in Middle East & North Africa (all income levels) in 1974 to that in 1979?
Keep it short and to the point. 0.95. What is the ratio of the Primary completion rate (% of total enrollments) in Congo (Republic) in 1974 to that in 1979?
Provide a short and direct response. 0.78. What is the ratio of the Primary completion rate (% of total enrollments) in Libya in 1974 to that in 1979?
Your answer should be very brief. 0.99. What is the ratio of the Primary completion rate (% of total enrollments) of Netherlands in 1974 to that in 1979?
Ensure brevity in your answer.  1.03. What is the ratio of the Primary completion rate (% of total enrollments) of Middle East & North Africa (all income levels) in 1975 to that in 1976?
Give a very brief answer. 0.97. What is the ratio of the Primary completion rate (% of total enrollments) of Congo (Republic) in 1975 to that in 1976?
Your answer should be compact. 0.99. What is the ratio of the Primary completion rate (% of total enrollments) in Libya in 1975 to that in 1976?
Offer a terse response. 1.06. What is the ratio of the Primary completion rate (% of total enrollments) in Libya in 1975 to that in 1977?
Give a very brief answer. 1.07. What is the ratio of the Primary completion rate (% of total enrollments) of Netherlands in 1975 to that in 1977?
Provide a succinct answer. 1.01. What is the ratio of the Primary completion rate (% of total enrollments) in Middle East & North Africa (all income levels) in 1975 to that in 1978?
Offer a terse response. 0.94. What is the ratio of the Primary completion rate (% of total enrollments) in Congo (Republic) in 1975 to that in 1978?
Keep it short and to the point. 0.97. What is the ratio of the Primary completion rate (% of total enrollments) in Libya in 1975 to that in 1978?
Make the answer very short. 1.09. What is the ratio of the Primary completion rate (% of total enrollments) of Netherlands in 1975 to that in 1978?
Offer a terse response. 1.03. What is the ratio of the Primary completion rate (% of total enrollments) in Congo (Republic) in 1975 to that in 1979?
Your answer should be very brief. 0.89. What is the ratio of the Primary completion rate (% of total enrollments) in Libya in 1975 to that in 1979?
Your answer should be compact. 1.14. What is the ratio of the Primary completion rate (% of total enrollments) of Netherlands in 1975 to that in 1979?
Your response must be concise. 1.03. What is the ratio of the Primary completion rate (% of total enrollments) of Middle East & North Africa (all income levels) in 1976 to that in 1977?
Ensure brevity in your answer.  0.96. What is the ratio of the Primary completion rate (% of total enrollments) of Congo (Republic) in 1976 to that in 1977?
Provide a succinct answer. 0.97. What is the ratio of the Primary completion rate (% of total enrollments) of Libya in 1976 to that in 1977?
Provide a short and direct response. 1.01. What is the ratio of the Primary completion rate (% of total enrollments) in Netherlands in 1976 to that in 1977?
Your response must be concise. 1.01. What is the ratio of the Primary completion rate (% of total enrollments) of Middle East & North Africa (all income levels) in 1976 to that in 1978?
Provide a short and direct response. 0.96. What is the ratio of the Primary completion rate (% of total enrollments) in Congo (Republic) in 1976 to that in 1978?
Make the answer very short. 0.98. What is the ratio of the Primary completion rate (% of total enrollments) in Netherlands in 1976 to that in 1978?
Ensure brevity in your answer.  1.03. What is the ratio of the Primary completion rate (% of total enrollments) in Middle East & North Africa (all income levels) in 1976 to that in 1979?
Provide a succinct answer. 1.03. What is the ratio of the Primary completion rate (% of total enrollments) in Congo (Republic) in 1976 to that in 1979?
Give a very brief answer. 0.9. What is the ratio of the Primary completion rate (% of total enrollments) in Libya in 1976 to that in 1979?
Offer a very short reply. 1.08. What is the ratio of the Primary completion rate (% of total enrollments) in Netherlands in 1976 to that in 1979?
Your answer should be compact. 1.03. What is the ratio of the Primary completion rate (% of total enrollments) of Congo (Republic) in 1977 to that in 1978?
Offer a very short reply. 1.01. What is the ratio of the Primary completion rate (% of total enrollments) of Libya in 1977 to that in 1978?
Give a very brief answer. 1.02. What is the ratio of the Primary completion rate (% of total enrollments) in Netherlands in 1977 to that in 1978?
Keep it short and to the point. 1.02. What is the ratio of the Primary completion rate (% of total enrollments) in Middle East & North Africa (all income levels) in 1977 to that in 1979?
Provide a succinct answer. 1.07. What is the ratio of the Primary completion rate (% of total enrollments) in Congo (Republic) in 1977 to that in 1979?
Your answer should be compact. 0.93. What is the ratio of the Primary completion rate (% of total enrollments) of Libya in 1977 to that in 1979?
Keep it short and to the point. 1.07. What is the ratio of the Primary completion rate (% of total enrollments) of Netherlands in 1977 to that in 1979?
Give a very brief answer. 1.03. What is the ratio of the Primary completion rate (% of total enrollments) of Middle East & North Africa (all income levels) in 1978 to that in 1979?
Offer a terse response. 1.07. What is the ratio of the Primary completion rate (% of total enrollments) of Congo (Republic) in 1978 to that in 1979?
Your response must be concise. 0.92. What is the ratio of the Primary completion rate (% of total enrollments) in Libya in 1978 to that in 1979?
Offer a very short reply. 1.05. What is the ratio of the Primary completion rate (% of total enrollments) in Netherlands in 1978 to that in 1979?
Make the answer very short. 1. What is the difference between the highest and the second highest Primary completion rate (% of total enrollments) in Middle East & North Africa (all income levels)?
Offer a very short reply. 0.18. What is the difference between the highest and the second highest Primary completion rate (% of total enrollments) in Congo (Republic)?
Give a very brief answer. 5.8. What is the difference between the highest and the second highest Primary completion rate (% of total enrollments) of Libya?
Keep it short and to the point. 6.76. What is the difference between the highest and the second highest Primary completion rate (% of total enrollments) in Netherlands?
Keep it short and to the point. 0.6. What is the difference between the highest and the lowest Primary completion rate (% of total enrollments) of Middle East & North Africa (all income levels)?
Make the answer very short. 10.39. What is the difference between the highest and the lowest Primary completion rate (% of total enrollments) of Congo (Republic)?
Offer a terse response. 18.78. What is the difference between the highest and the lowest Primary completion rate (% of total enrollments) in Libya?
Keep it short and to the point. 33.11. What is the difference between the highest and the lowest Primary completion rate (% of total enrollments) in Netherlands?
Your answer should be very brief. 3.71. 